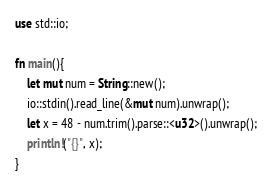<code> <loc_0><loc_0><loc_500><loc_500><_Rust_>use std::io;

fn main(){
    let mut num = String::new();
    io::stdin().read_line(&mut num).unwrap();
    let x = 48 - num.trim().parse::<u32>().unwrap();
    println!("{}", x); 
}
</code> 